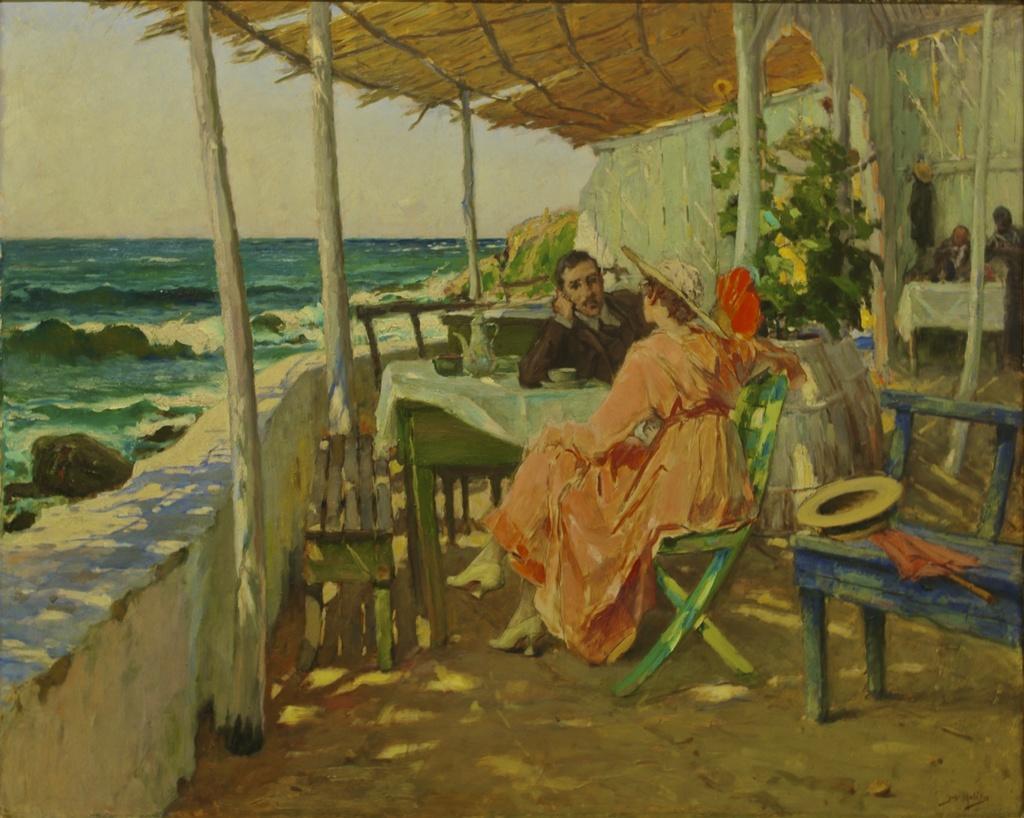Describe this image in one or two sentences. There is a man sitting on a chair and placing hand on the table, on which, there is a cup on the saucer, a jug and other objects, near a woman, who is sitting on another chair, which is on the floor. On the left side, there is a wall, near wooden poles and tent. On the right side, there are other persons, pot plant, which is having flowers and other furniture. In the background, there is an ocean and there is sky. 